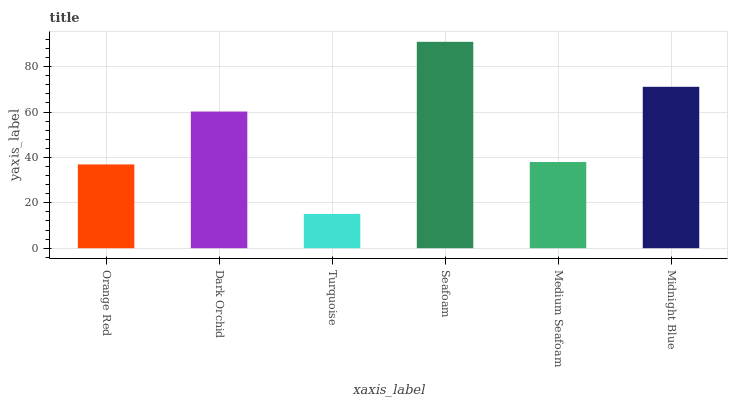Is Dark Orchid the minimum?
Answer yes or no. No. Is Dark Orchid the maximum?
Answer yes or no. No. Is Dark Orchid greater than Orange Red?
Answer yes or no. Yes. Is Orange Red less than Dark Orchid?
Answer yes or no. Yes. Is Orange Red greater than Dark Orchid?
Answer yes or no. No. Is Dark Orchid less than Orange Red?
Answer yes or no. No. Is Dark Orchid the high median?
Answer yes or no. Yes. Is Medium Seafoam the low median?
Answer yes or no. Yes. Is Midnight Blue the high median?
Answer yes or no. No. Is Midnight Blue the low median?
Answer yes or no. No. 